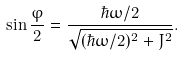Convert formula to latex. <formula><loc_0><loc_0><loc_500><loc_500>\sin \frac { \varphi } { 2 } = \frac { \hbar { \omega } / 2 } { \sqrt { ( \hbar { \omega } / 2 ) ^ { 2 } + J ^ { 2 } } } .</formula> 